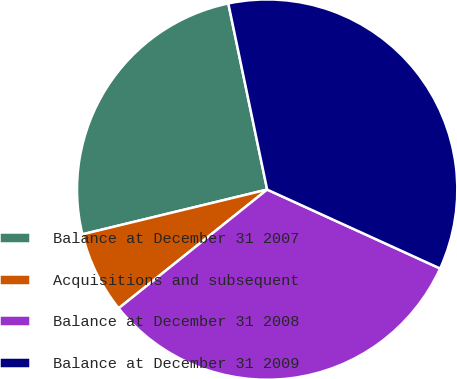Convert chart to OTSL. <chart><loc_0><loc_0><loc_500><loc_500><pie_chart><fcel>Balance at December 31 2007<fcel>Acquisitions and subsequent<fcel>Balance at December 31 2008<fcel>Balance at December 31 2009<nl><fcel>25.51%<fcel>6.95%<fcel>32.46%<fcel>35.09%<nl></chart> 